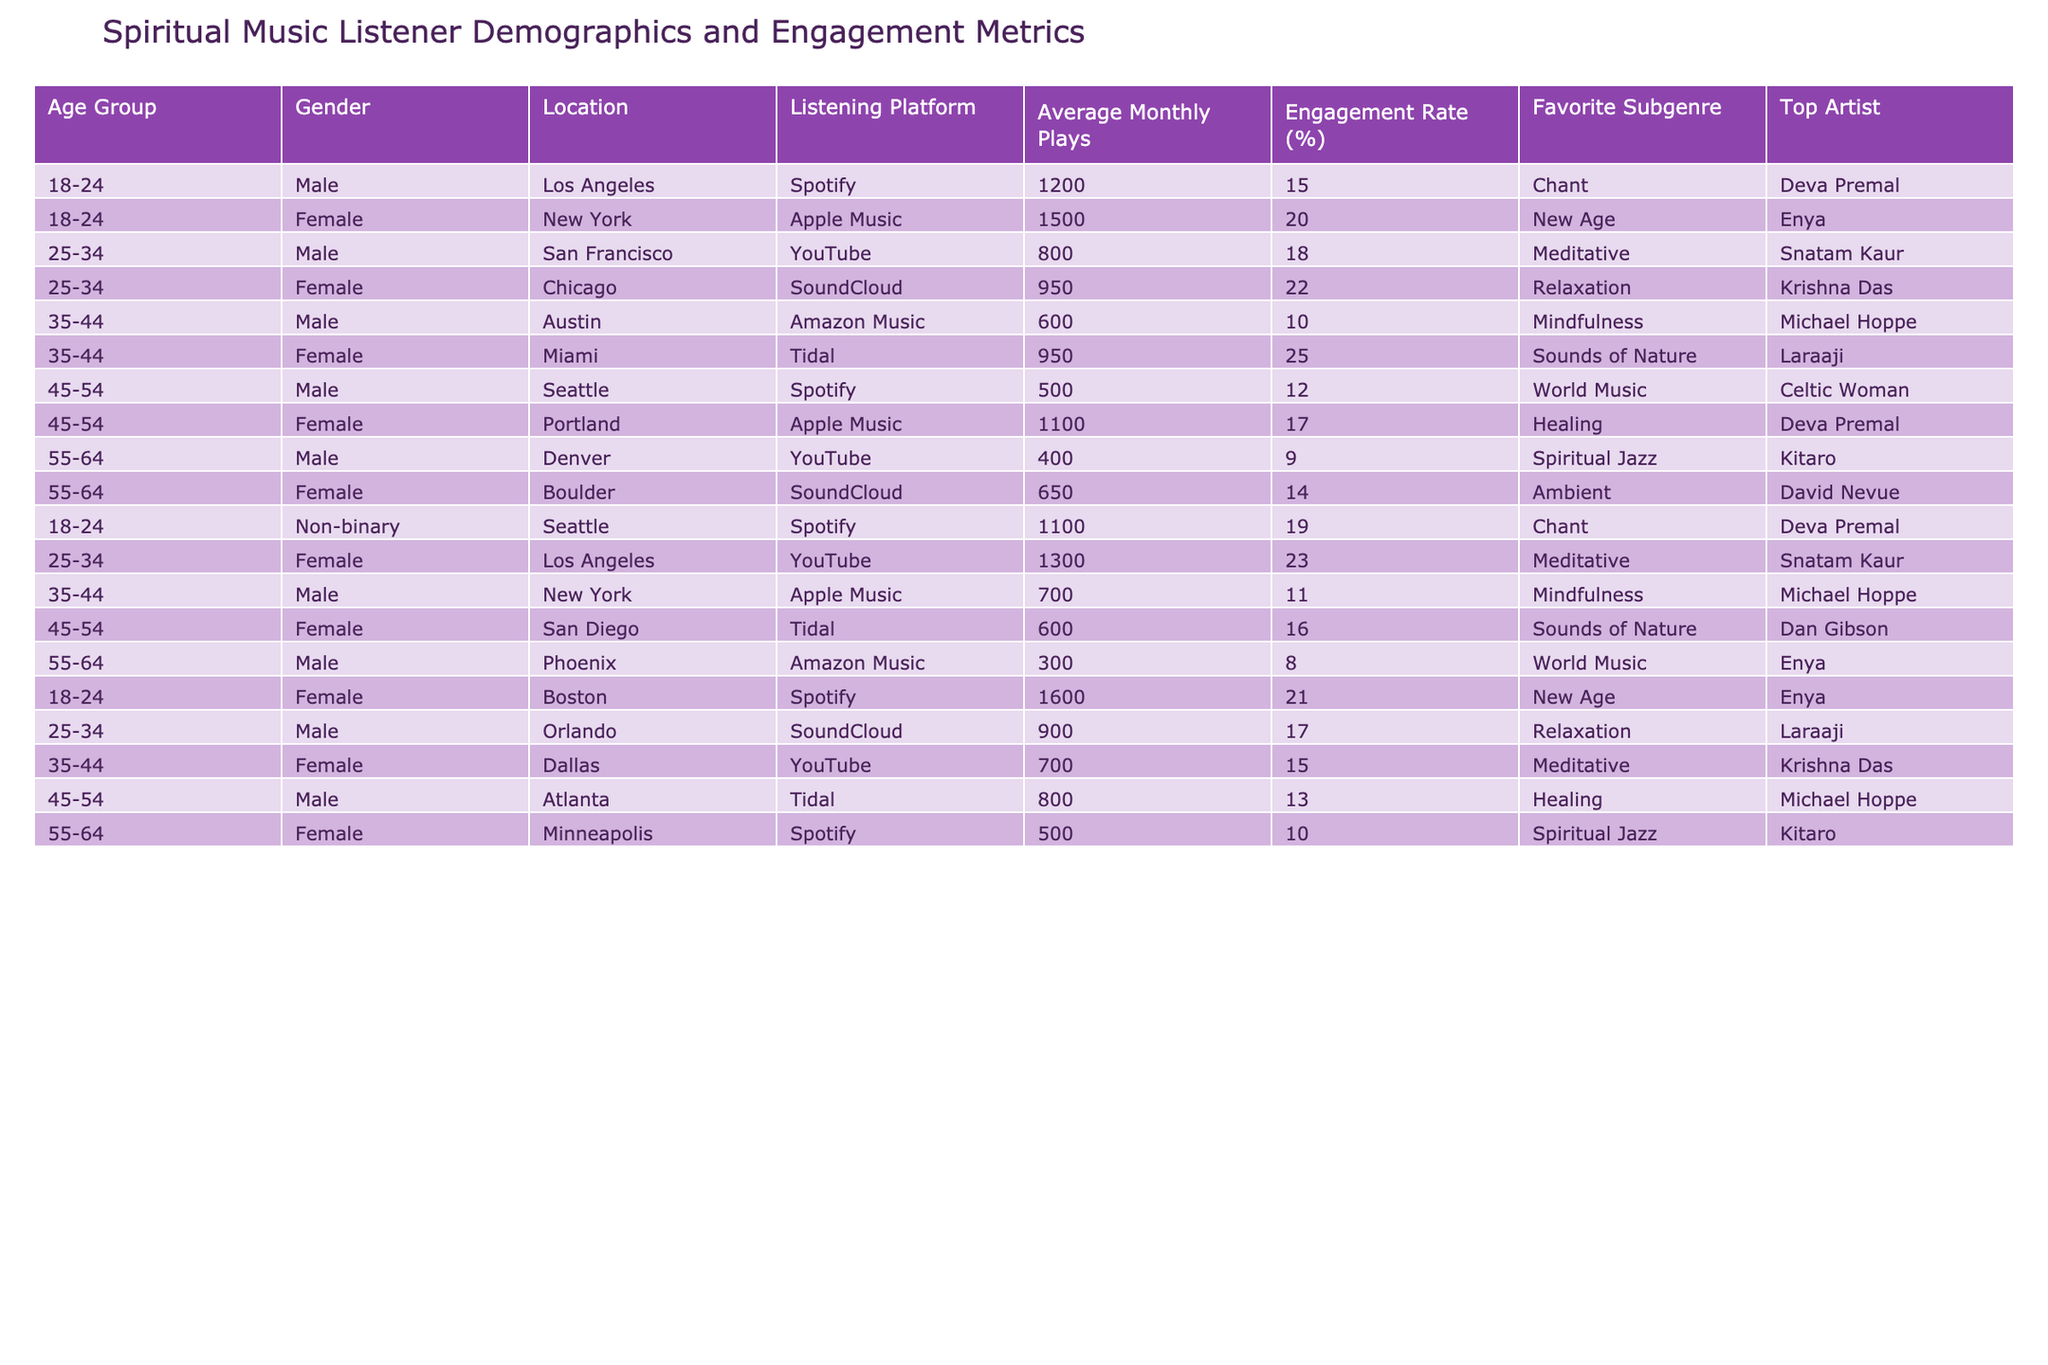What is the average engagement rate for the 25-34 age group? The engagement rates for the 25-34 age group are 18, 22, 23, and 17. Adding these values gives 18 + 22 + 23 + 17 = 80. There are 4 entries, so the average is 80 / 4 = 20.
Answer: 20 Which gender has the highest average monthly plays in the 35-44 age group? The average monthly plays for males in this group are 600 and for females are 700. Since 700 is greater than 600, females have the highest average.
Answer: Female Is there any listener in the 45-54 age group who has an engagement rate above 15%? The engagement rates for the 45-54 age group are 12, 17, 13, and 16. Checking through these values, we can see that 17 and 16 are above 15%, confirming that there are listeners with such engagement rates.
Answer: Yes What is the total average monthly plays for all listeners who favor the 'Meditative' subgenre? The average monthly plays for those who prefer 'Meditative' are 800, 950, and 700. Summing these gives 800 + 950 + 700 = 2450 and dividing by 3 gives an average of 2450 / 3 ≈ 816.67, which rounds to 817.
Answer: 817 Which city has the highest engagement rate, and what is that rate? The engagement rates for various cities are: Los Angeles (15), New York (20), San Francisco (18), Chicago (22), Austin (10), Miami (25), Seattle (12), Portland (17), Boulder (14), Denver (9), Atlanta (13), and San Diego (16). The highest is 25 from Miami.
Answer: Miami, 25 Are there any non-binary listeners in the table? There is one entry for a non-binary listener in Seattle. Therefore, the statement is true.
Answer: Yes What is the difference in average monthly plays between the 'Chant' and 'New Age' subgenres? The average monthly plays for 'Chant' are 1200 and 1100, totaling 2300 from 2 entries, giving an average of 1150. For 'New Age', the only entry is 1500. Thus, the difference is 1500 - 1150 = 350.
Answer: 350 How many listeners are there from the location 'Los Angeles'? There are 2 entries for Los Angeles in the table.
Answer: 2 What proportion of listeners in the 55-64 age group are female? There are 5 total listeners in the 55-64 age group (2 males and 3 females). Thus, the proportion of female listeners is 3 out of 5, which is 60%.
Answer: 60% What subgenre is preferred by the male listeners from Chicago? The male listener from Chicago prefers the 'Relaxation' subgenre.
Answer: Relaxation 